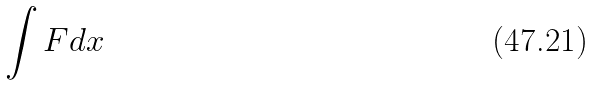Convert formula to latex. <formula><loc_0><loc_0><loc_500><loc_500>\int F d x</formula> 